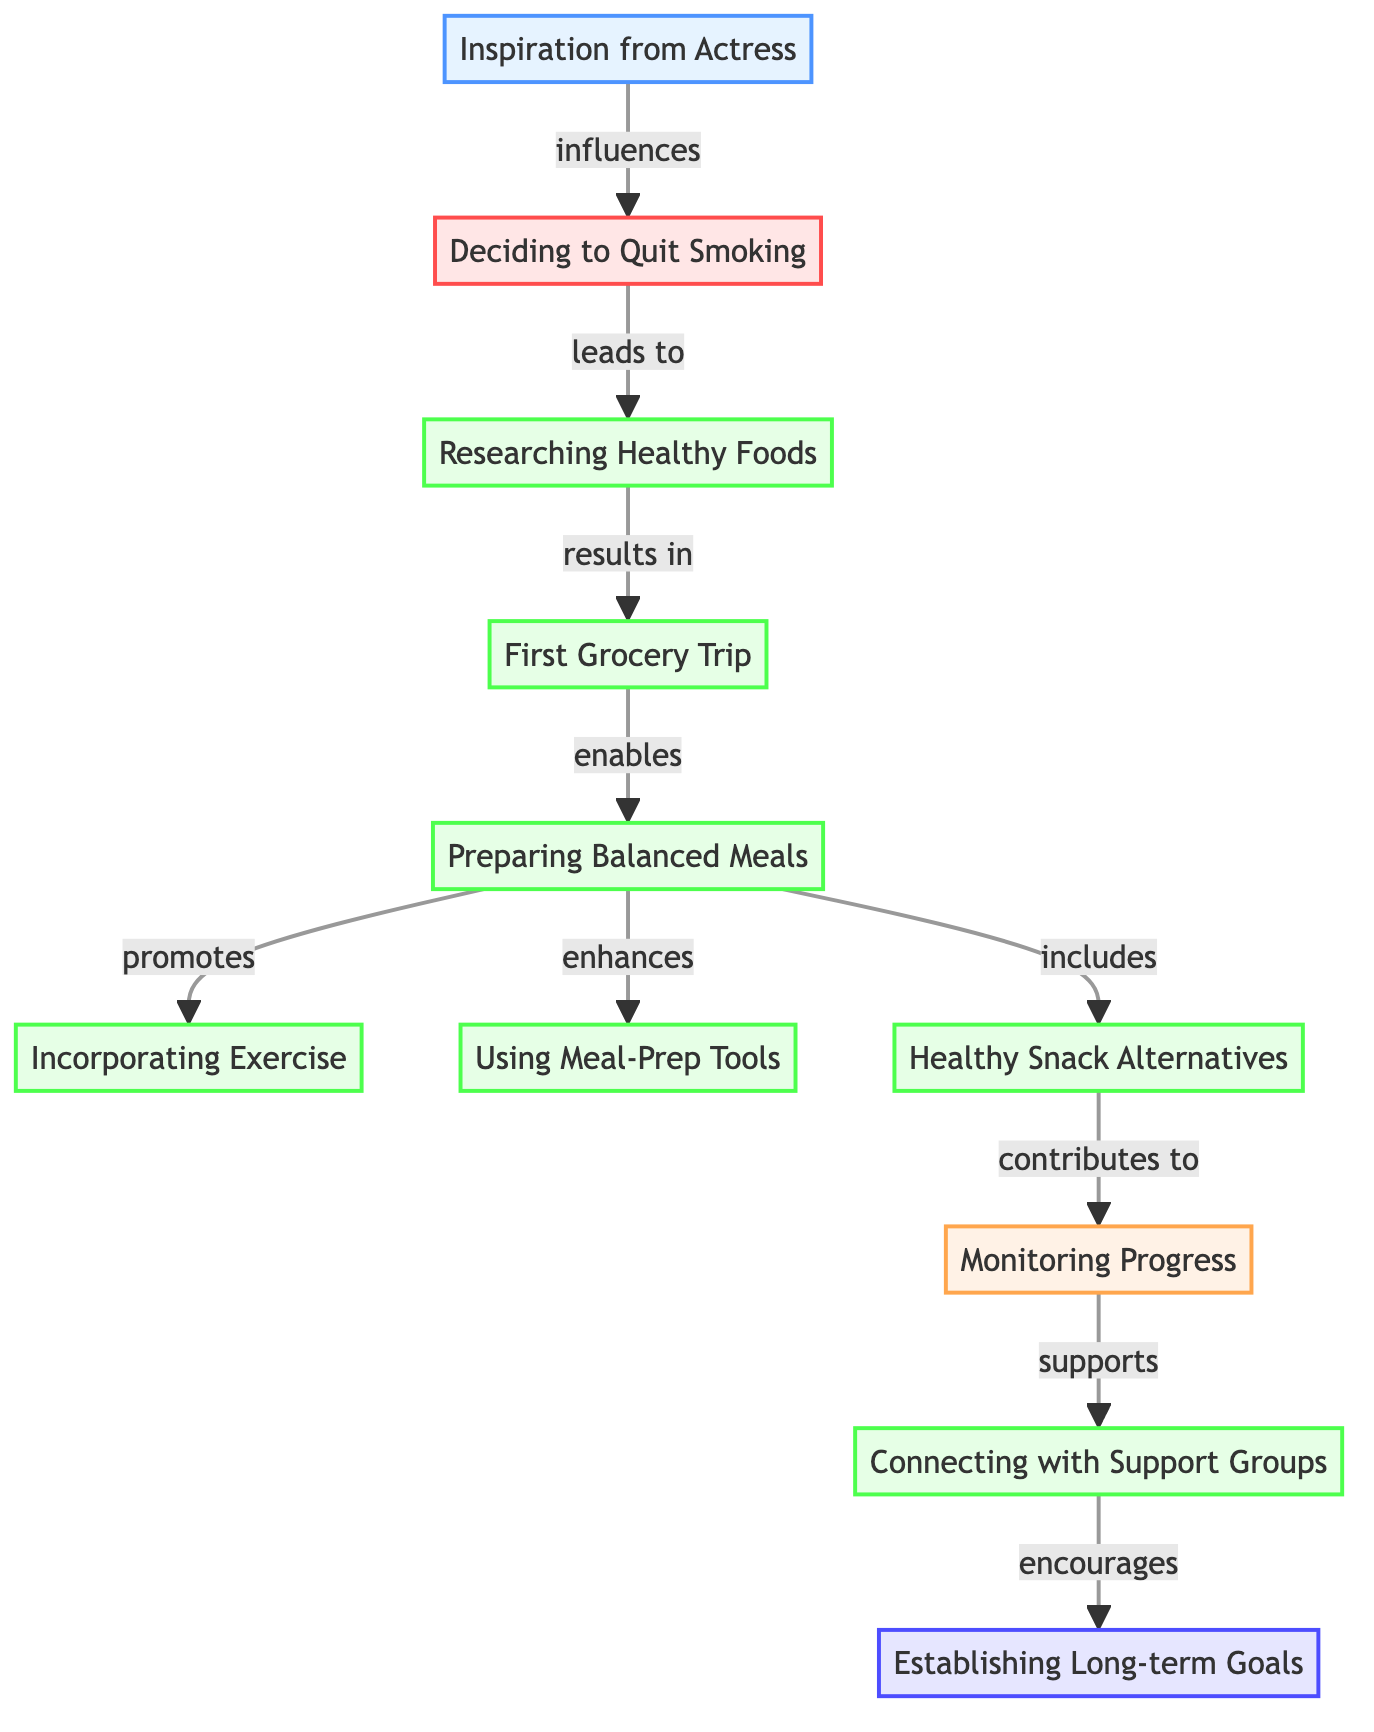What is the starting point of the journey? The starting point of the journey is represented by the node labeled "Inspiration from Actress." This node influences the decision to quit smoking, making it the initial step in the graph.
Answer: Inspiration from Actress How many nodes are in the diagram? To determine the number of nodes, we count each distinct point within the diagram. There are 11 nodes listed in the data provided.
Answer: 11 Which node follows the decision to quit smoking? The node that follows the decision to quit smoking, represented as "Deciding to Quit Smoking," is "Researching Healthy Foods." This is indicated by the directed edge leading from node 2 to node 3.
Answer: Researching Healthy Foods What does "Preparing Balanced Meals" enable? "Preparing Balanced Meals" (node 5) enables "Incorporating Exercise" (node 6), "Using Meal-Prep Tools" (node 7), and "Healthy Snack Alternatives" (node 8). The edge leading from node 5 clearly shows these connections.
Answer: Incorporating Exercise, Using Meal-Prep Tools, Healthy Snack Alternatives How does "Healthy Snack Alternatives" contribute to the journey? "Healthy Snack Alternatives" provides a connection to "Monitoring Progress," indicating that implementing healthier snack options positively impacts progress tracking. This is shown by the directed edge from node 8 to node 9.
Answer: Monitoring Progress What is the final step in establishing a healthy lifestyle? The final step in the journey is represented by "Establishing Long-term Goals." This node is reached following the connections from "Connecting with Support Groups," indicating that it is the endpoint of the journey towards a balanced lifestyle.
Answer: Establishing Long-term Goals What relationship does "Researching Healthy Foods" have with "First Grocery Trip"? "Researching Healthy Foods" results in "First Grocery Trip," indicating that the knowledge gained leads directly to making the first grocery purchase. The edge connecting nodes 3 and 4 illustrates this relationship.
Answer: results in Which node shows the impact of monitoring progress? The node that demonstrates the impact of monitoring progress is "Connecting with Support Groups." It is connected from "Monitoring Progress," suggesting that tracking improvements is essential for connecting with supportive communities.
Answer: Connecting with Support Groups 